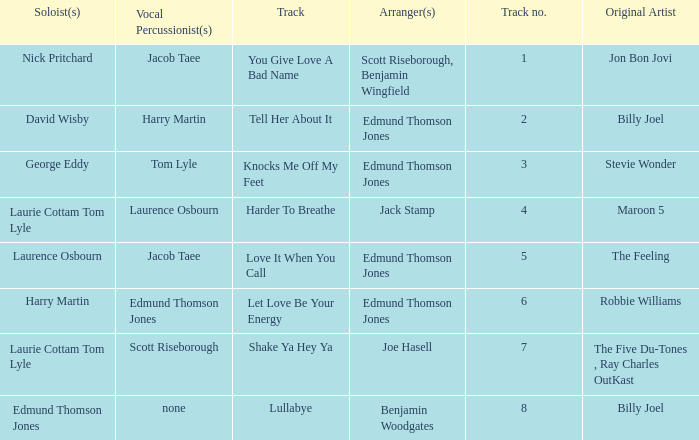How many tracks have the title let love be your energy? 1.0. 